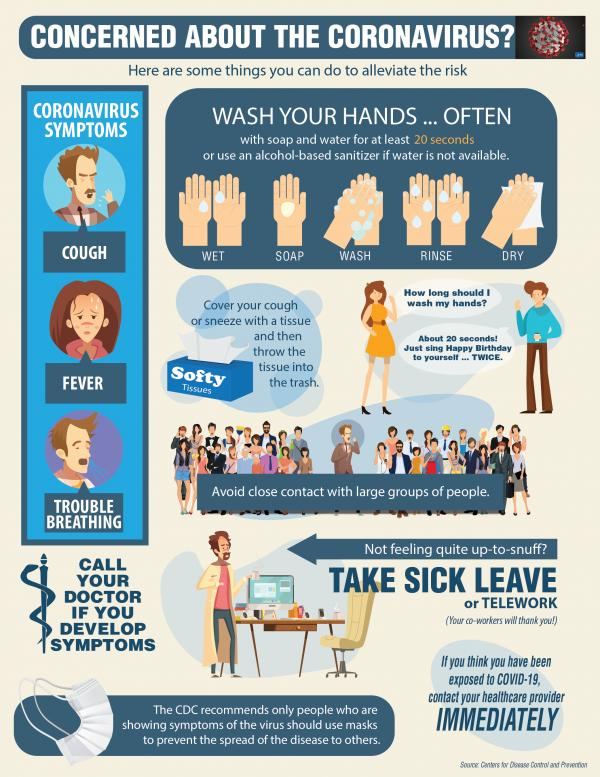Point out several critical features in this image. There are three symptoms of the coronavirus represented in this infographic. The infographic mentions a tissue referred to as "softy tissue". 